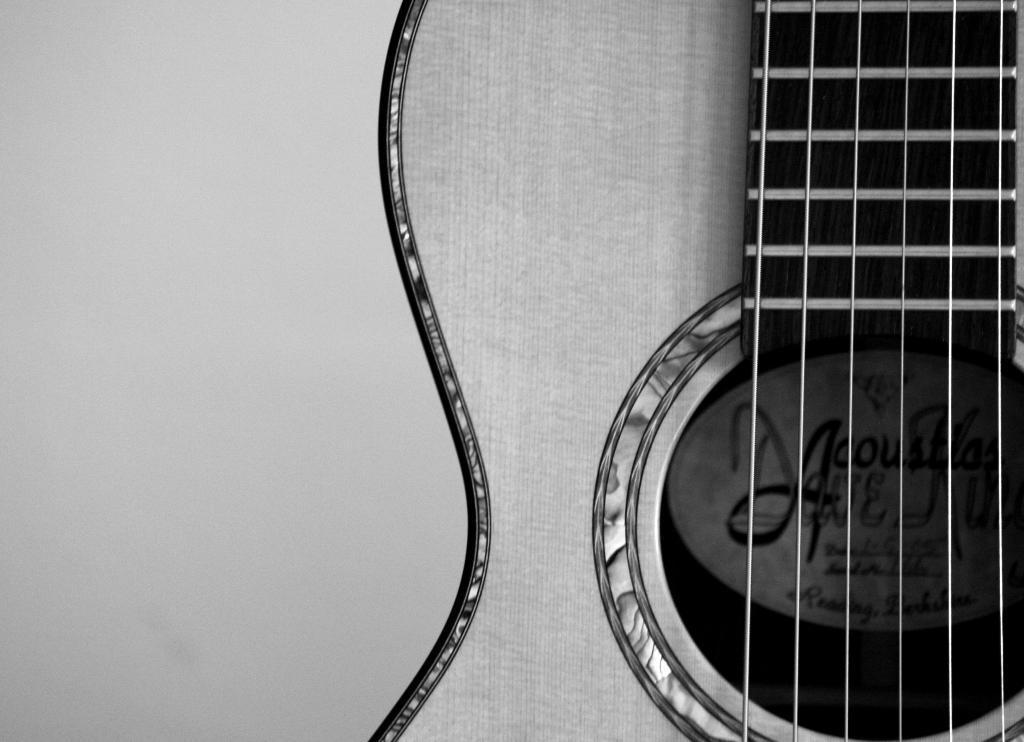In one or two sentences, can you explain what this image depicts? In this image I can see a guitar. 